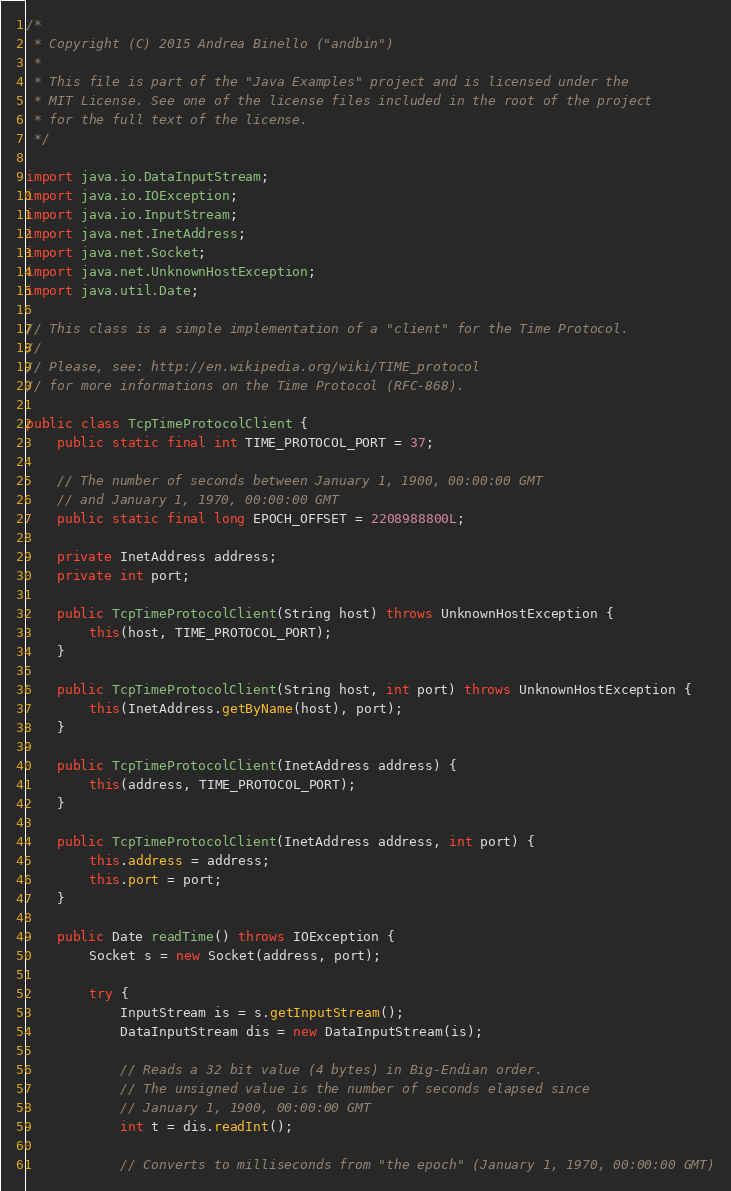Convert code to text. <code><loc_0><loc_0><loc_500><loc_500><_Java_>/*
 * Copyright (C) 2015 Andrea Binello ("andbin")
 *
 * This file is part of the "Java Examples" project and is licensed under the
 * MIT License. See one of the license files included in the root of the project
 * for the full text of the license.
 */

import java.io.DataInputStream;
import java.io.IOException;
import java.io.InputStream;
import java.net.InetAddress;
import java.net.Socket;
import java.net.UnknownHostException;
import java.util.Date;

// This class is a simple implementation of a "client" for the Time Protocol.
//
// Please, see: http://en.wikipedia.org/wiki/TIME_protocol
// for more informations on the Time Protocol (RFC-868).

public class TcpTimeProtocolClient {
	public static final int TIME_PROTOCOL_PORT = 37;

	// The number of seconds between January 1, 1900, 00:00:00 GMT
	// and January 1, 1970, 00:00:00 GMT
	public static final long EPOCH_OFFSET = 2208988800L;

	private InetAddress address;
	private int port;

	public TcpTimeProtocolClient(String host) throws UnknownHostException {
		this(host, TIME_PROTOCOL_PORT);
	}

	public TcpTimeProtocolClient(String host, int port) throws UnknownHostException {
		this(InetAddress.getByName(host), port);
	}

	public TcpTimeProtocolClient(InetAddress address) {
		this(address, TIME_PROTOCOL_PORT);
	}

	public TcpTimeProtocolClient(InetAddress address, int port) {
		this.address = address;
		this.port = port;
	}

	public Date readTime() throws IOException {
		Socket s = new Socket(address, port);

		try {
			InputStream is = s.getInputStream();
			DataInputStream dis = new DataInputStream(is);

			// Reads a 32 bit value (4 bytes) in Big-Endian order.
			// The unsigned value is the number of seconds elapsed since
			// January 1, 1900, 00:00:00 GMT
			int t = dis.readInt();

			// Converts to milliseconds from "the epoch" (January 1, 1970, 00:00:00 GMT)</code> 